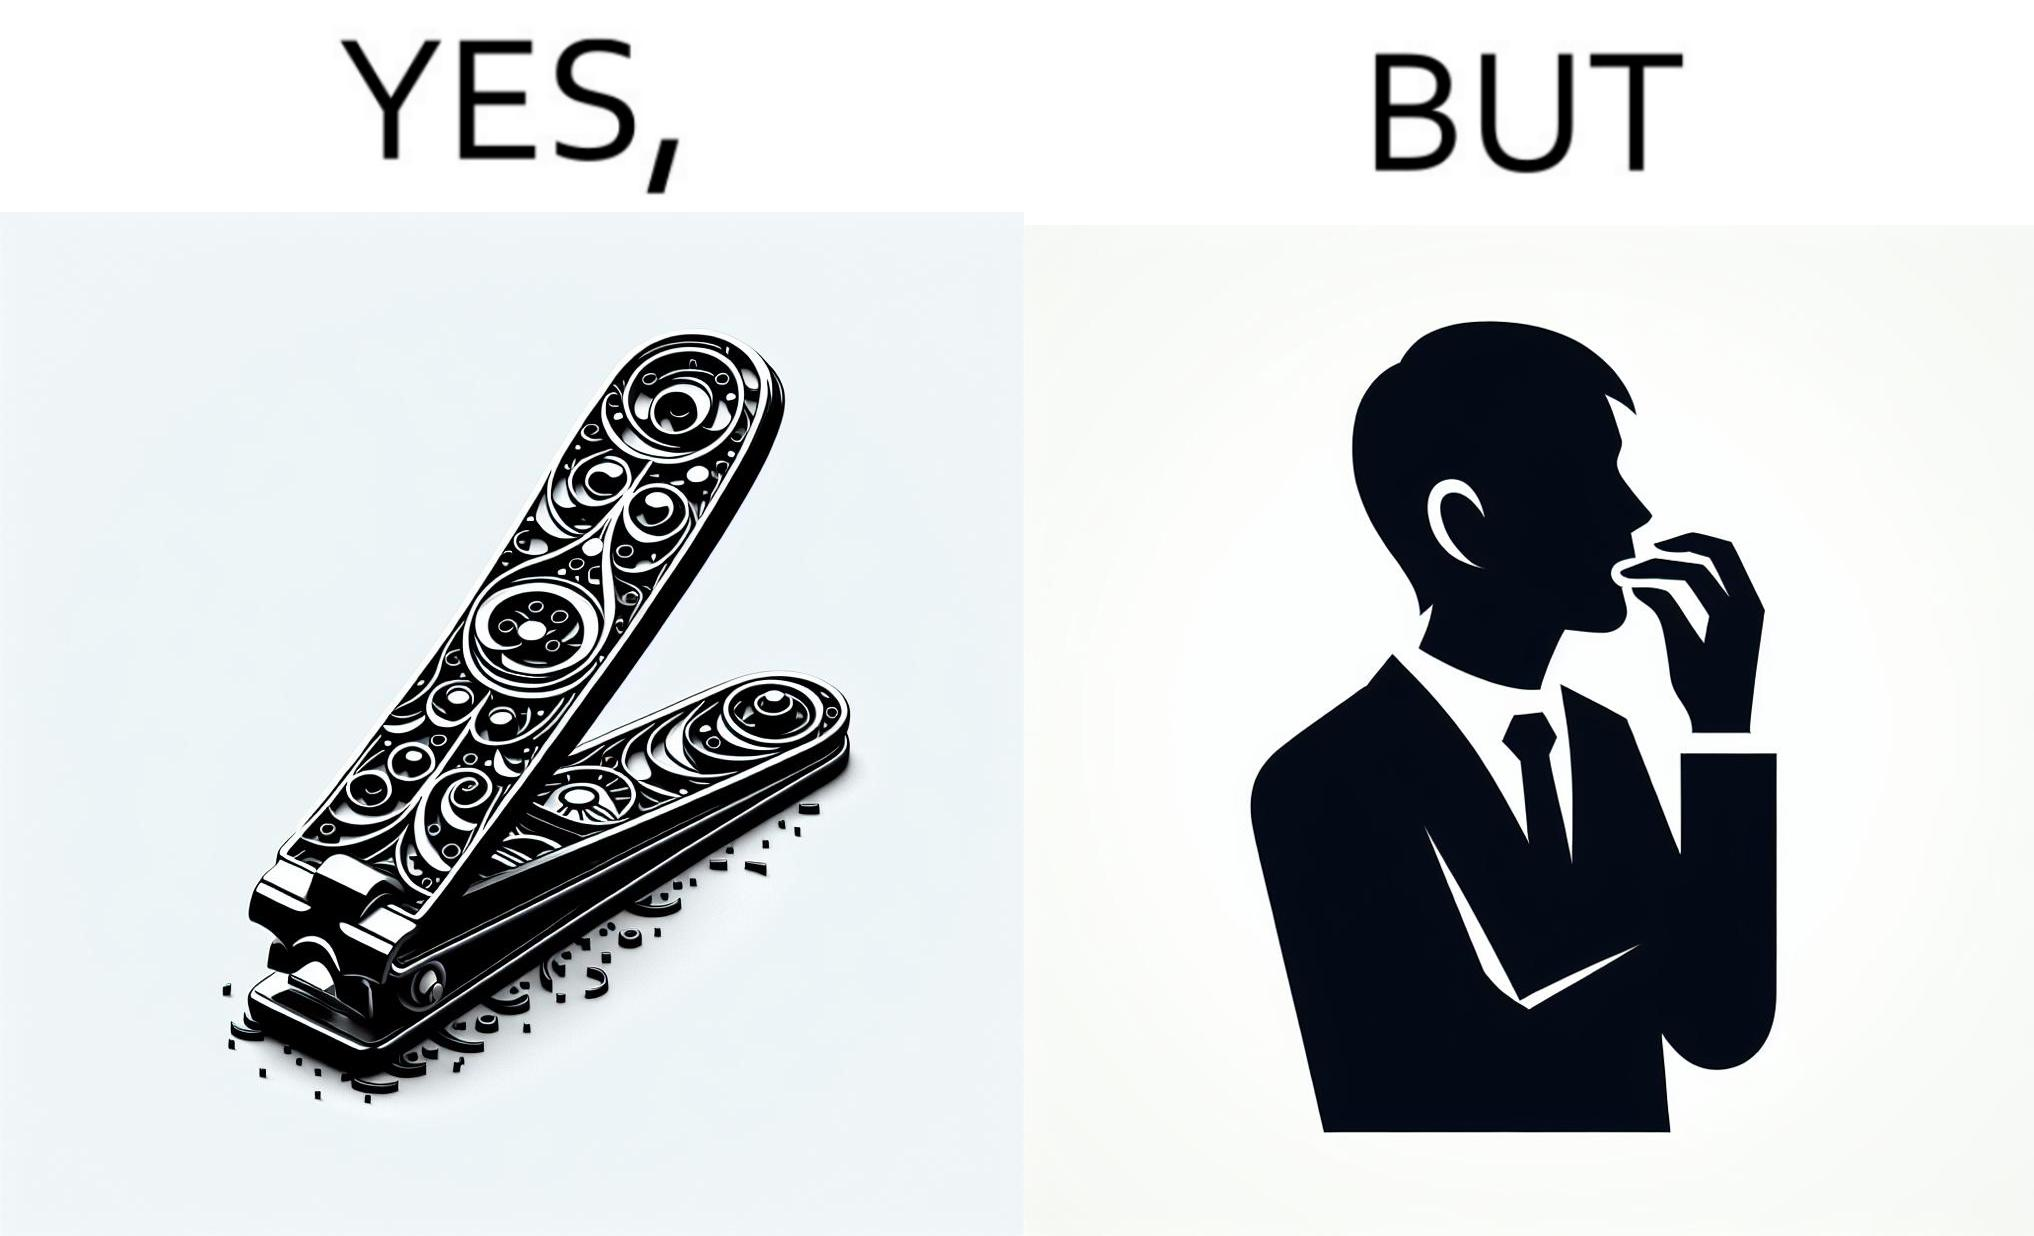What does this image depict? The image is ironic, because even after nail clippers are available people prefer biting their nails by teeth 